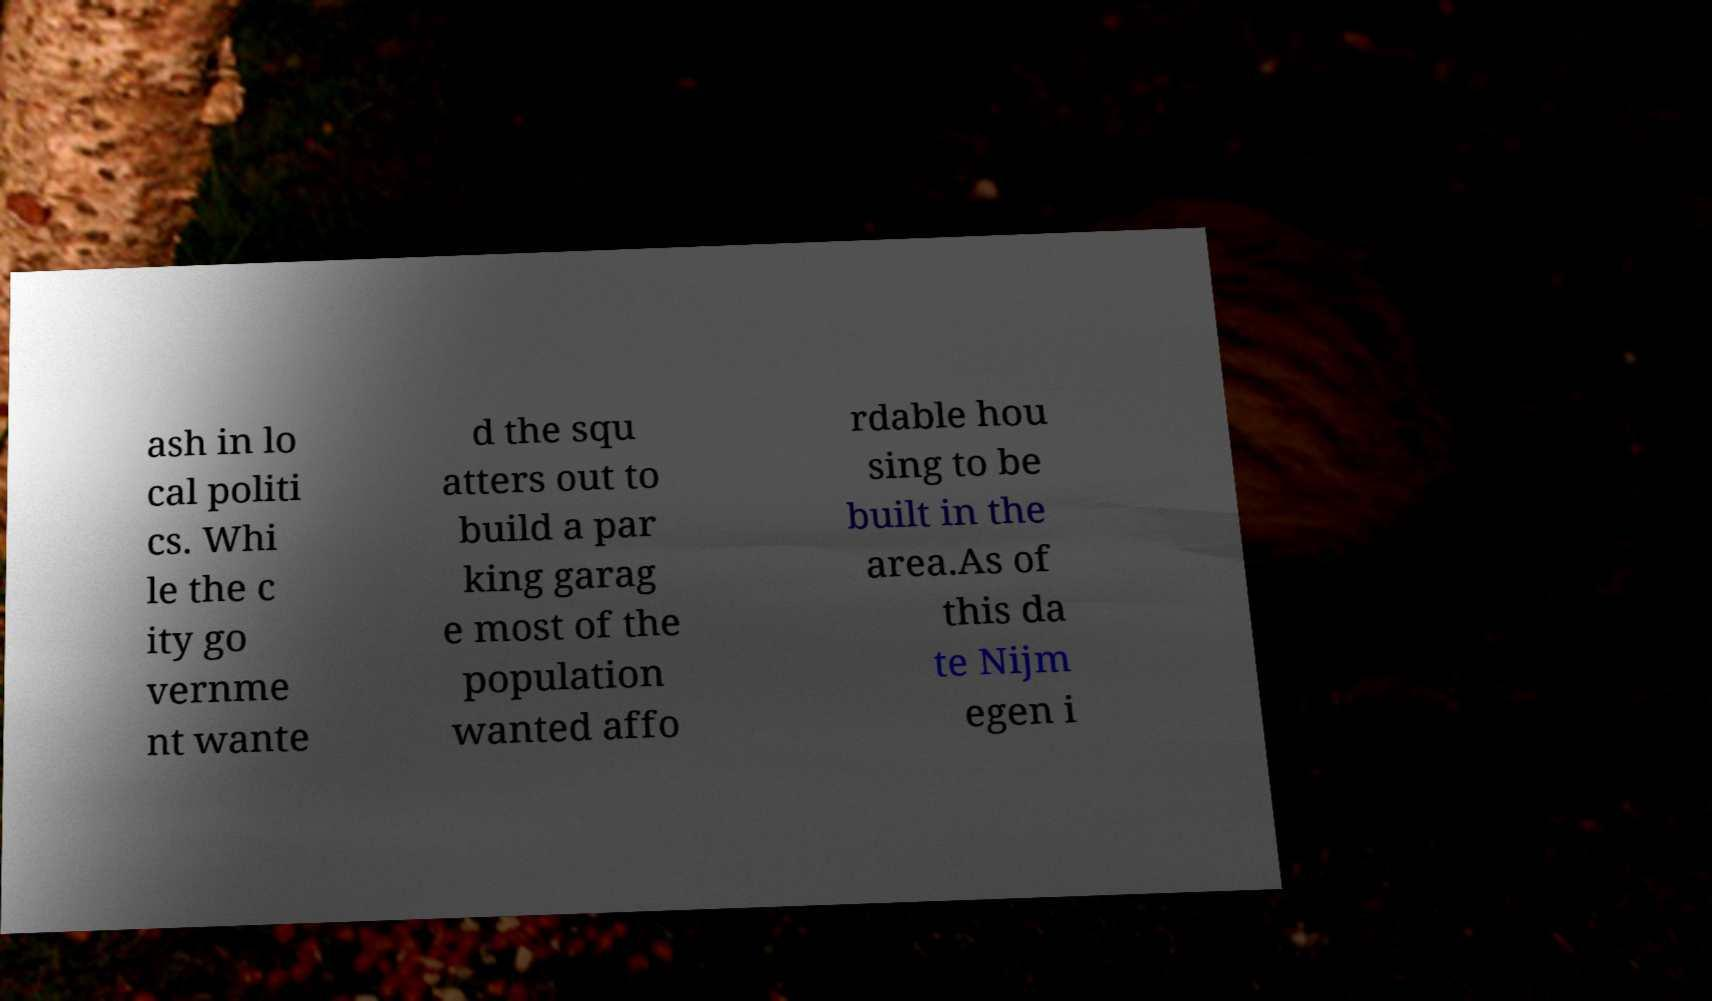Could you extract and type out the text from this image? ash in lo cal politi cs. Whi le the c ity go vernme nt wante d the squ atters out to build a par king garag e most of the population wanted affo rdable hou sing to be built in the area.As of this da te Nijm egen i 